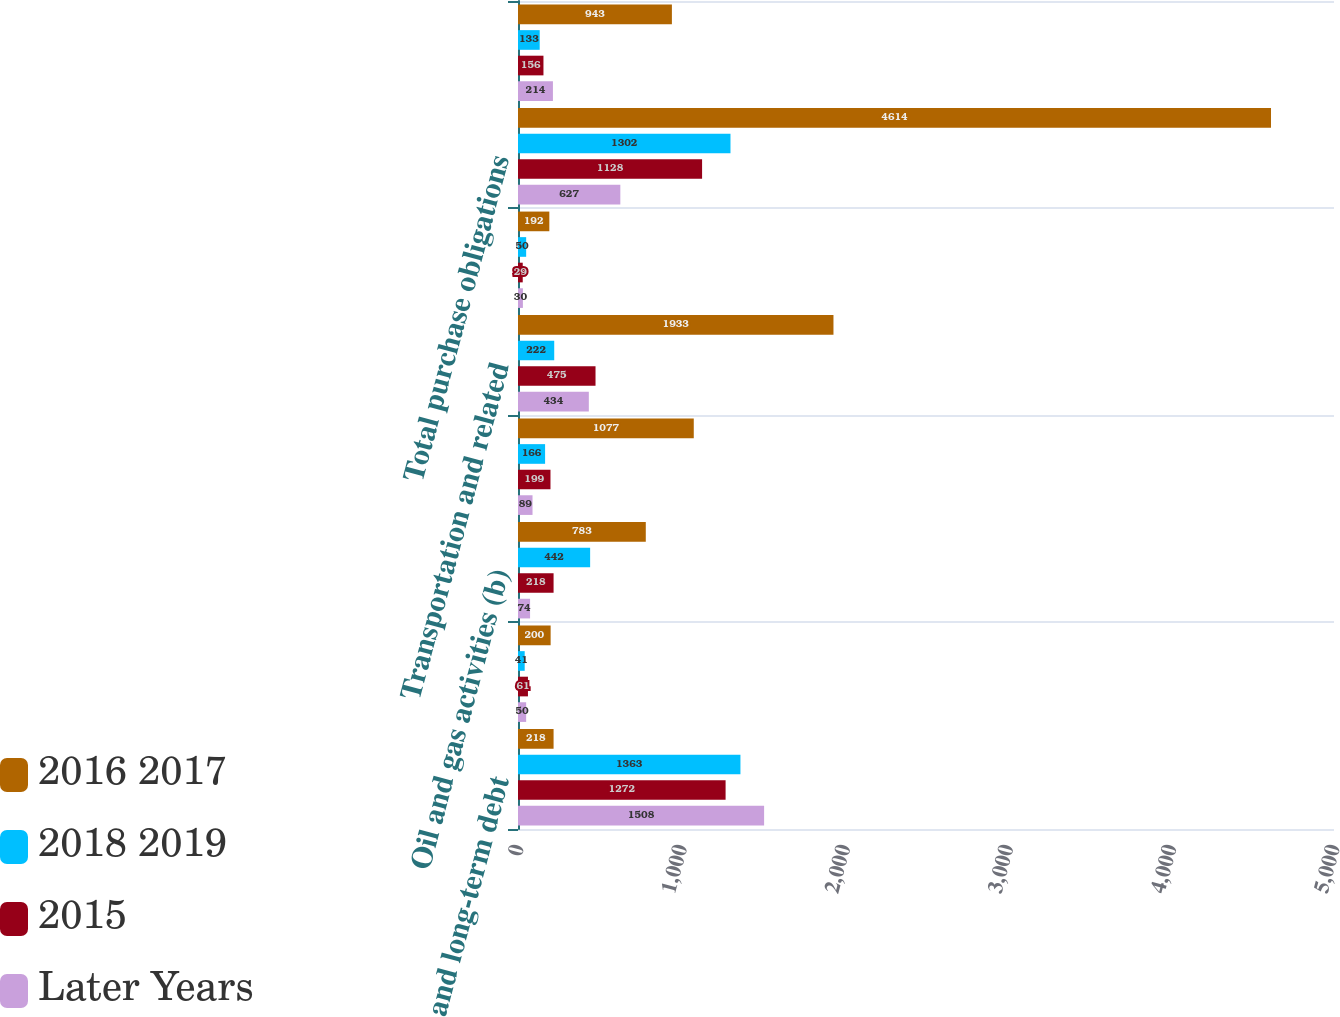Convert chart. <chart><loc_0><loc_0><loc_500><loc_500><stacked_bar_chart><ecel><fcel>Short and long-term debt<fcel>Lease obligations<fcel>Oil and gas activities (b)<fcel>Service and materials<fcel>Transportation and related<fcel>Other<fcel>Total purchase obligations<fcel>Other long-term liabilities<nl><fcel>2016 2017<fcel>218<fcel>200<fcel>783<fcel>1077<fcel>1933<fcel>192<fcel>4614<fcel>943<nl><fcel>2018 2019<fcel>1363<fcel>41<fcel>442<fcel>166<fcel>222<fcel>50<fcel>1302<fcel>133<nl><fcel>2015<fcel>1272<fcel>61<fcel>218<fcel>199<fcel>475<fcel>29<fcel>1128<fcel>156<nl><fcel>Later Years<fcel>1508<fcel>50<fcel>74<fcel>89<fcel>434<fcel>30<fcel>627<fcel>214<nl></chart> 